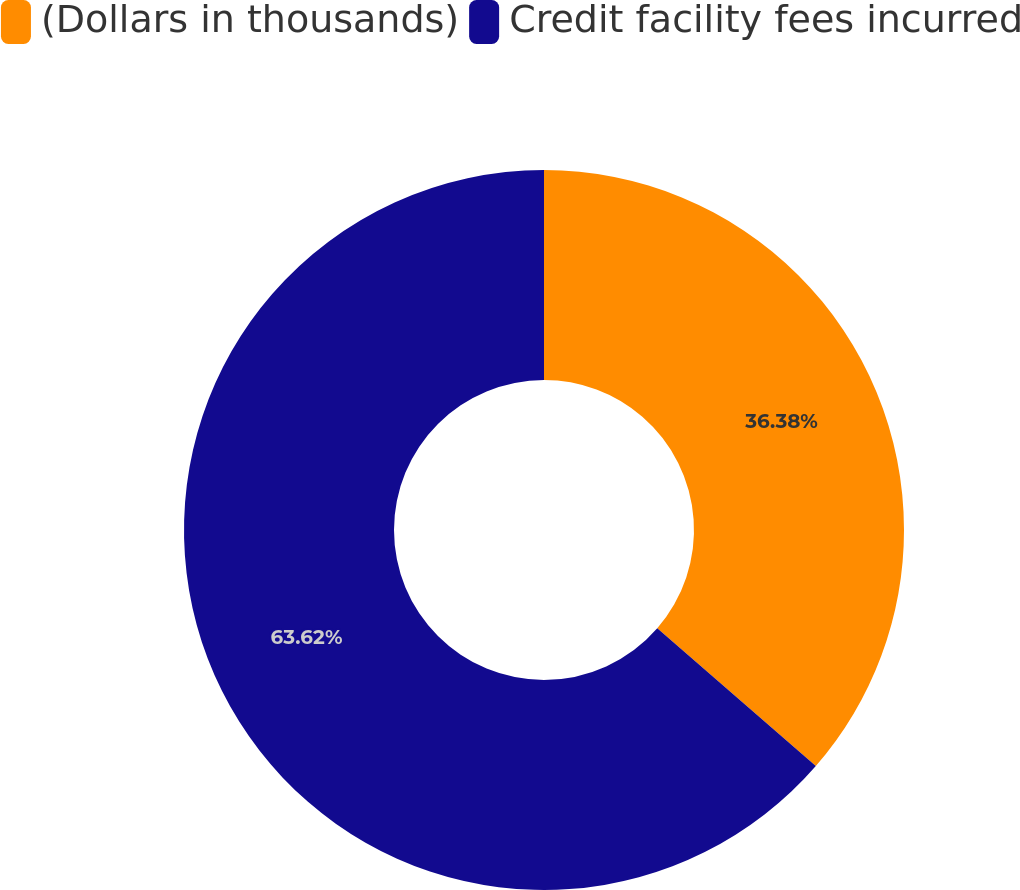Convert chart. <chart><loc_0><loc_0><loc_500><loc_500><pie_chart><fcel>(Dollars in thousands)<fcel>Credit facility fees incurred<nl><fcel>36.38%<fcel>63.62%<nl></chart> 